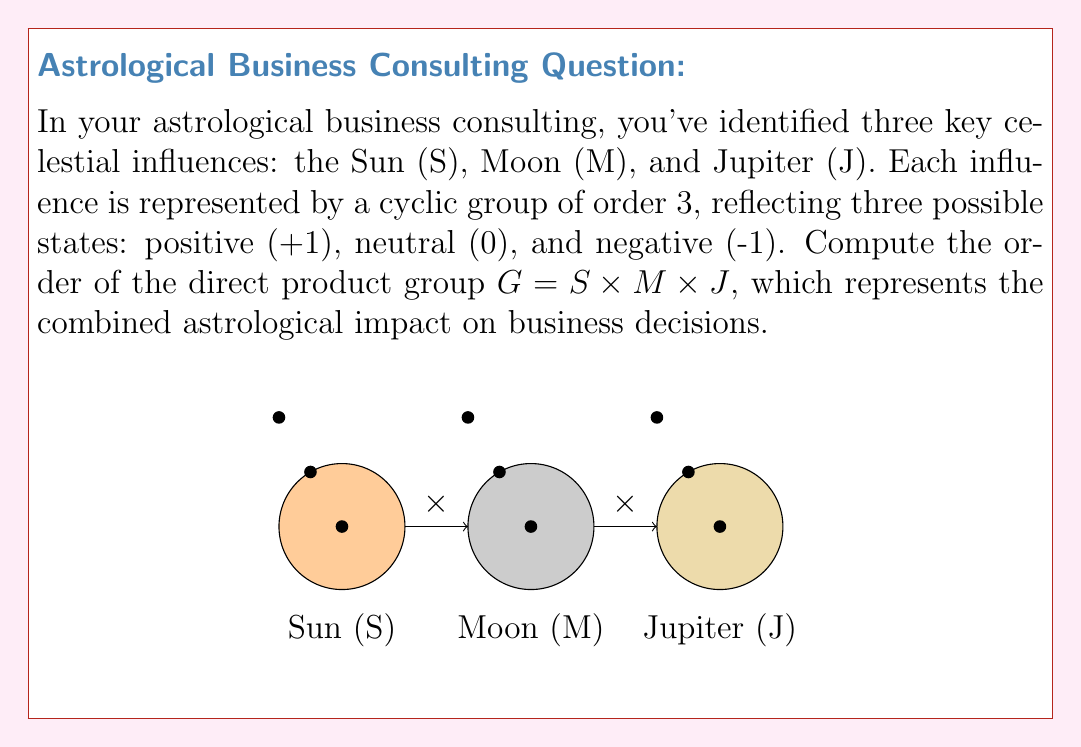What is the answer to this math problem? To solve this problem, we need to understand the properties of direct products of groups and apply them to our astrological influences:

1) Each celestial influence (Sun, Moon, Jupiter) is represented by a cyclic group of order 3. Let's call these groups $S$, $M$, and $J$ respectively.

2) The direct product of these groups is defined as $G = S \times M \times J$.

3) A fundamental theorem in group theory states that the order of a direct product of finite groups is equal to the product of the orders of the individual groups.

4) Mathematically, this is expressed as:
   $$|G| = |S \times M \times J| = |S| \cdot |M| \cdot |J|$$

5) We know that each group (S, M, J) has order 3:
   $$|S| = |M| = |J| = 3$$

6) Substituting these values into our equation:
   $$|G| = 3 \cdot 3 \cdot 3 = 27$$

Therefore, the order of the direct product group $G$, representing the combined astrological influence on business decisions, is 27.

This means there are 27 possible combined states of astrological influence in this system, each representing a unique combination of the Sun, Moon, and Jupiter's individual states.
Answer: $|G| = 27$ 